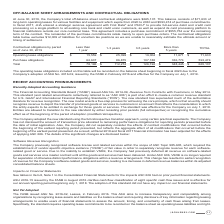From Jack Henry Associates's financial document, What are the 2 financial items shown in the table? The document shows two values: Operating lease obligations and Purchase obligations. From the document: "Operating lease obligations $ 15,559 $ 25,399 $ 19,004 $ 11,671 $ 71,633 Purchase obligations 62,637 86,875 107,188 336,774 593,474..." Also, What is the total operating lease obligations? According to the financial document, $71,633. The relevant text states: "bligations were $665,107. This balance consists of $71,633 of long-term operating leases for various facilities and equipment which expire from 2020 to 2030 an..." Also, What is the total purchase obligations? According to the financial document, 593,474. The relevant text states: "urchase obligations 62,637 86,875 107,188 336,774 593,474..." Additionally, Between total operating lease obligations and total purchase obligations, which is higher? Purchase obligations. The document states: "Purchase obligations 62,637 86,875 107,188 336,774 593,474..." Also, can you calculate: What percentage of total contractual obligations is the total operating lease obligations? Based on the calculation: $71,633/$665,107, the result is 10.77 (percentage). This is based on the information: "l off-balance sheet contractual obligations were $665,107. This balance consists of $71,633 of long-term operating leases for various facilities and equipmen igations were $665,107. This balance consi..." The key data points involved are: 665,107, 71,633. Also, can you calculate: What percentage of total contractual obligations is the total purchase obligations? Based on the calculation: 593,474/665,107, the result is 89.23 (percentage). This is based on the information: "urchase obligations 62,637 86,875 107,188 336,774 593,474 l off-balance sheet contractual obligations were $665,107. This balance consists of $71,633 of long-term operating leases for various faciliti..." The key data points involved are: 593,474, 665,107. 